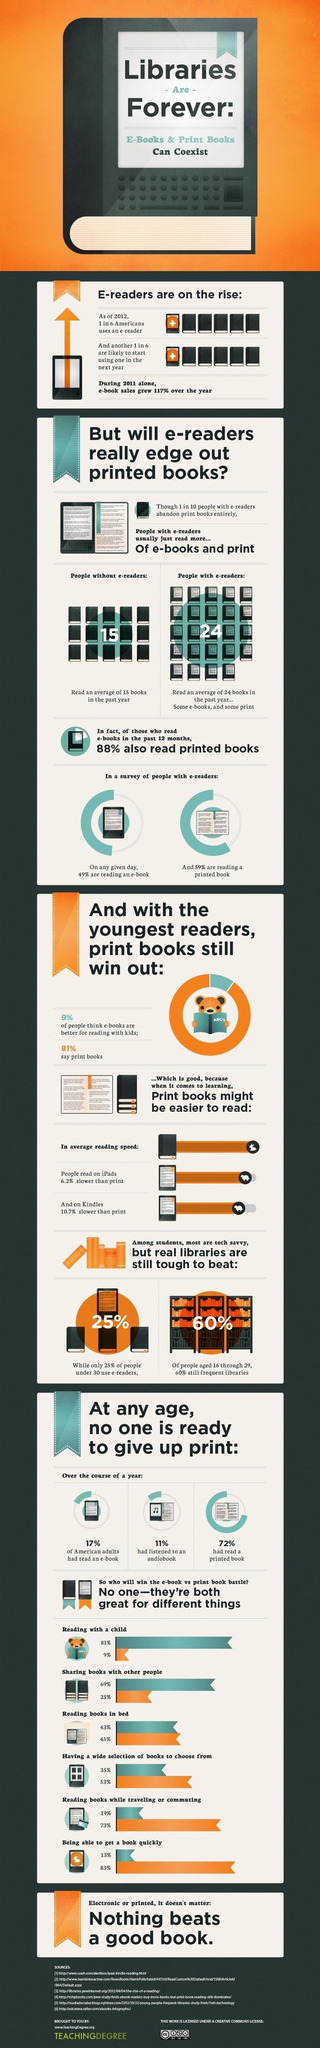What percentage had read a printed book over a year?
Answer the question with a short phrase. 72% What percentage of people had listened to an audiobook over a year? 11% What percentage of American adults had read an e-book over a year? 17% What percentage of people under 30 didn't use e-readers? 75% 